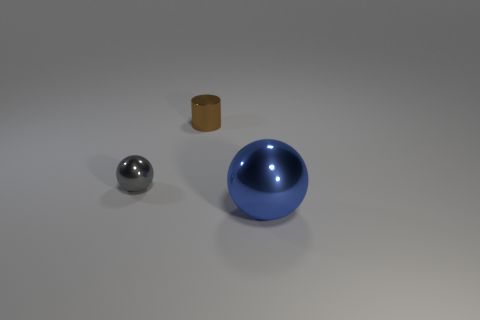Add 3 big red rubber cylinders. How many objects exist? 6 Subtract all balls. How many objects are left? 1 Add 1 tiny brown rubber balls. How many tiny brown rubber balls exist? 1 Subtract 0 gray cylinders. How many objects are left? 3 Subtract all tiny metal balls. Subtract all large blue things. How many objects are left? 1 Add 1 small things. How many small things are left? 3 